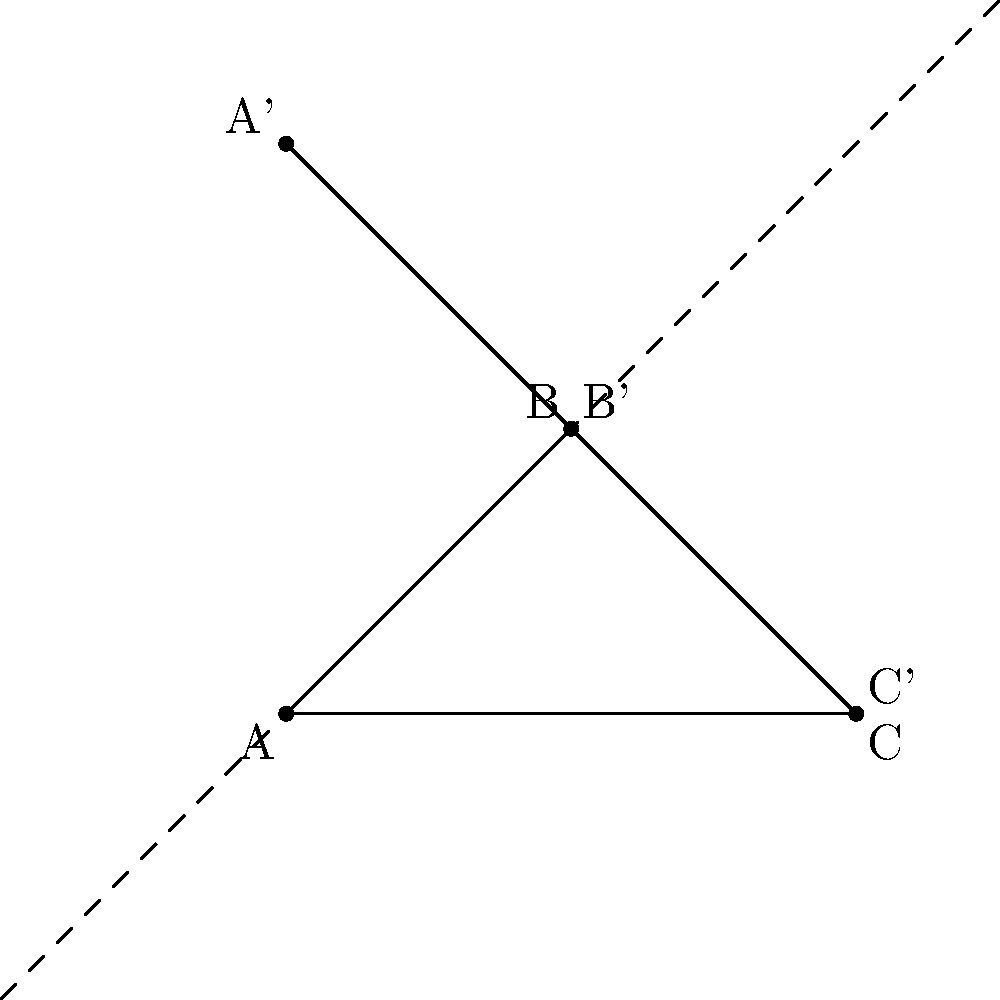In the coordinate plane above, the character's name "ABC" is reflected across the line $y=x$. What are the coordinates of point A' after the reflection? To find the coordinates of A' after reflecting point A across the line $y=x$, we follow these steps:

1. Identify the original coordinates of point A: $(1,1)$

2. For reflection across $y=x$, we swap the $x$ and $y$ coordinates:
   - The $x$-coordinate becomes the $y$-coordinate
   - The $y$-coordinate becomes the $x$-coordinate

3. Therefore, the reflection of A$(1,1)$ across $y=x$ is A'$(1,5)$:
   - New $x$-coordinate = original $y$-coordinate = 1
   - New $y$-coordinate = original $x$-coordinate = 5

4. Verify visually that A' is indeed at $(1,5)$ in the given coordinate plane

This reflection method is particularly relevant for a translator working with screenplays, as it could represent how characters' positions or relationships might be mirrored or transformed in adapted versions of a story.
Answer: $(1,5)$ 